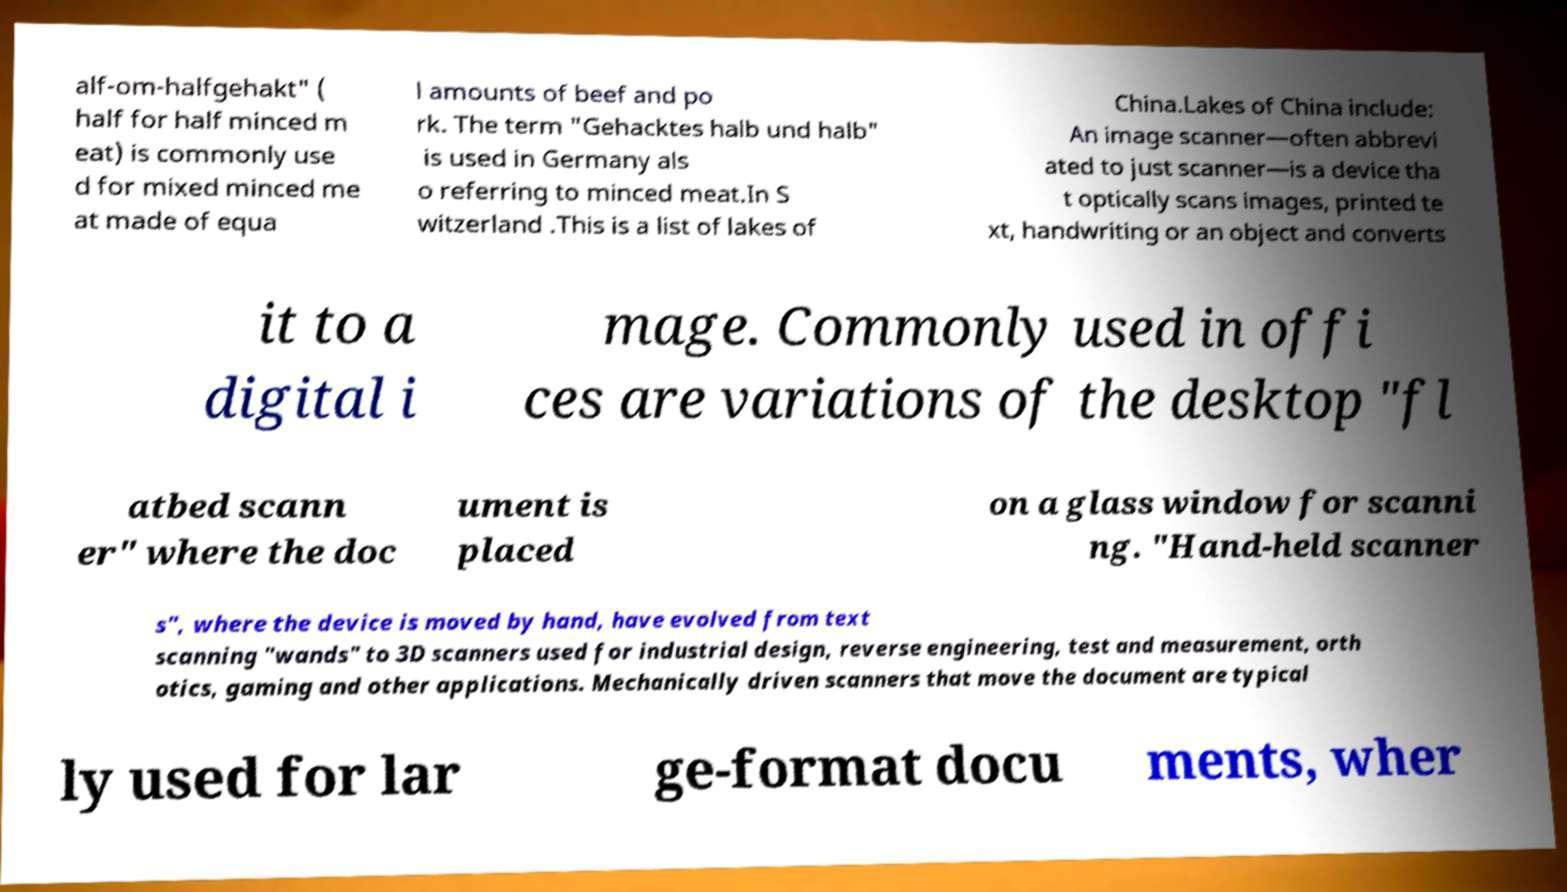Can you accurately transcribe the text from the provided image for me? alf-om-halfgehakt" ( half for half minced m eat) is commonly use d for mixed minced me at made of equa l amounts of beef and po rk. The term "Gehacktes halb und halb" is used in Germany als o referring to minced meat.In S witzerland .This is a list of lakes of China.Lakes of China include: An image scanner—often abbrevi ated to just scanner—is a device tha t optically scans images, printed te xt, handwriting or an object and converts it to a digital i mage. Commonly used in offi ces are variations of the desktop "fl atbed scann er" where the doc ument is placed on a glass window for scanni ng. "Hand-held scanner s", where the device is moved by hand, have evolved from text scanning "wands" to 3D scanners used for industrial design, reverse engineering, test and measurement, orth otics, gaming and other applications. Mechanically driven scanners that move the document are typical ly used for lar ge-format docu ments, wher 